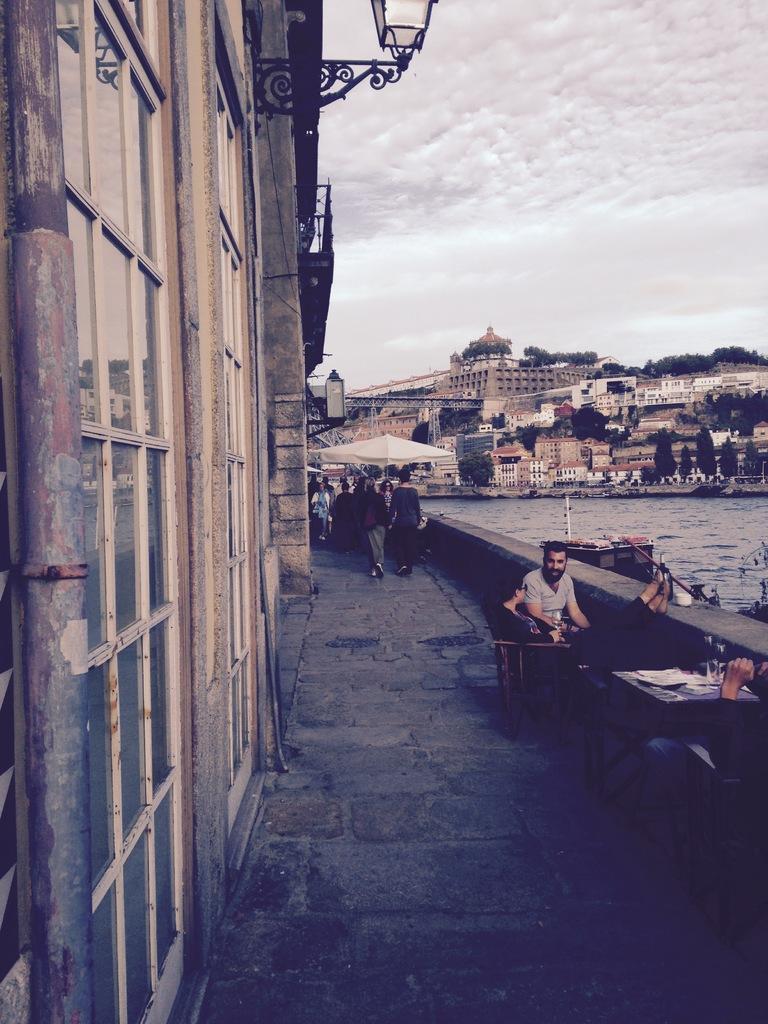Please provide a concise description of this image. In this image I see number of buildings and I see few trees and I see the water over here and I see number of people in which these 2 persons are sitting and I see a table over here on which there are few things on it and I see another person over here and I see the path. In the background I see the sky. 